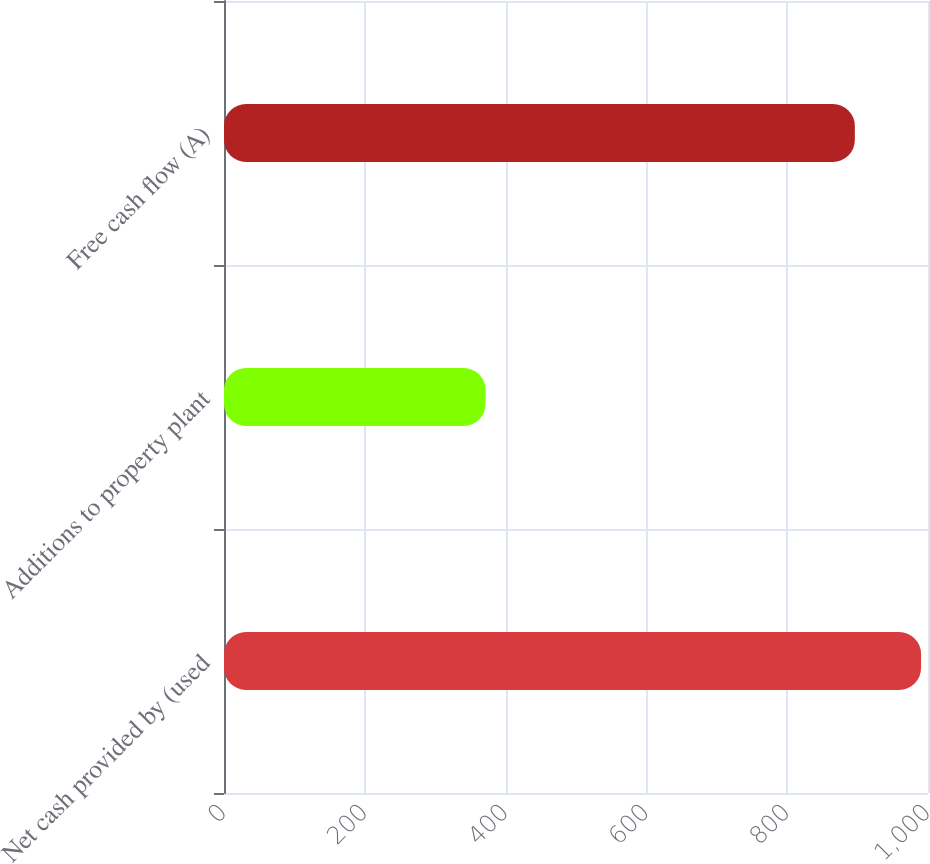<chart> <loc_0><loc_0><loc_500><loc_500><bar_chart><fcel>Net cash provided by (used<fcel>Additions to property plant<fcel>Free cash flow (A)<nl><fcel>990.14<fcel>371.64<fcel>896.1<nl></chart> 